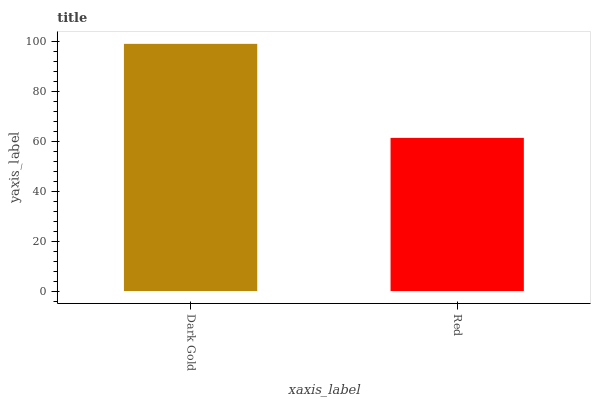Is Red the minimum?
Answer yes or no. Yes. Is Dark Gold the maximum?
Answer yes or no. Yes. Is Red the maximum?
Answer yes or no. No. Is Dark Gold greater than Red?
Answer yes or no. Yes. Is Red less than Dark Gold?
Answer yes or no. Yes. Is Red greater than Dark Gold?
Answer yes or no. No. Is Dark Gold less than Red?
Answer yes or no. No. Is Dark Gold the high median?
Answer yes or no. Yes. Is Red the low median?
Answer yes or no. Yes. Is Red the high median?
Answer yes or no. No. Is Dark Gold the low median?
Answer yes or no. No. 